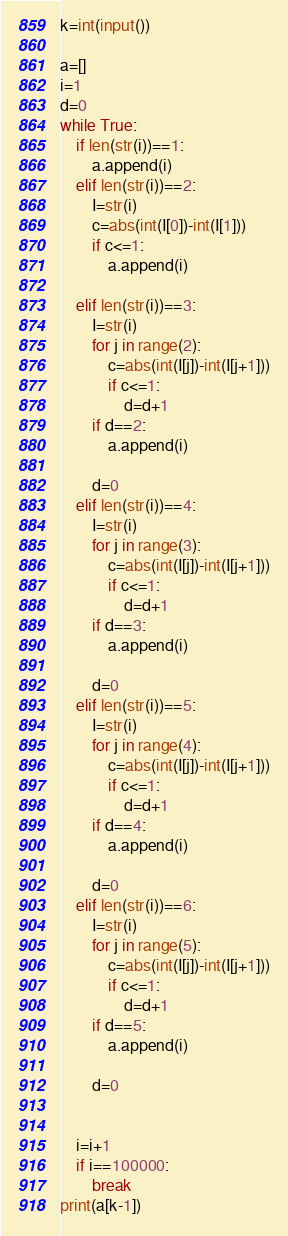Convert code to text. <code><loc_0><loc_0><loc_500><loc_500><_Python_>k=int(input())

a=[]
i=1
d=0
while True:
    if len(str(i))==1:
        a.append(i)
    elif len(str(i))==2:
        I=str(i)
        c=abs(int(I[0])-int(I[1]))
        if c<=1:
            a.append(i)
        
    elif len(str(i))==3:
        I=str(i)
        for j in range(2):
            c=abs(int(I[j])-int(I[j+1]))
            if c<=1:
                d=d+1
        if d==2:
            a.append(i)
            
        d=0
    elif len(str(i))==4:
        I=str(i)
        for j in range(3):
            c=abs(int(I[j])-int(I[j+1]))
            if c<=1:
                d=d+1
        if d==3:
            a.append(i)
            
        d=0
    elif len(str(i))==5:
        I=str(i)
        for j in range(4):
            c=abs(int(I[j])-int(I[j+1]))
            if c<=1:
                d=d+1
        if d==4:
            a.append(i)
            
        d=0
    elif len(str(i))==6:
        I=str(i)
        for j in range(5):
            c=abs(int(I[j])-int(I[j+1]))
            if c<=1:
                d=d+1
        if d==5:
            a.append(i)
            
        d=0
    
    
    i=i+1
    if i==100000:
        break
print(a[k-1])</code> 